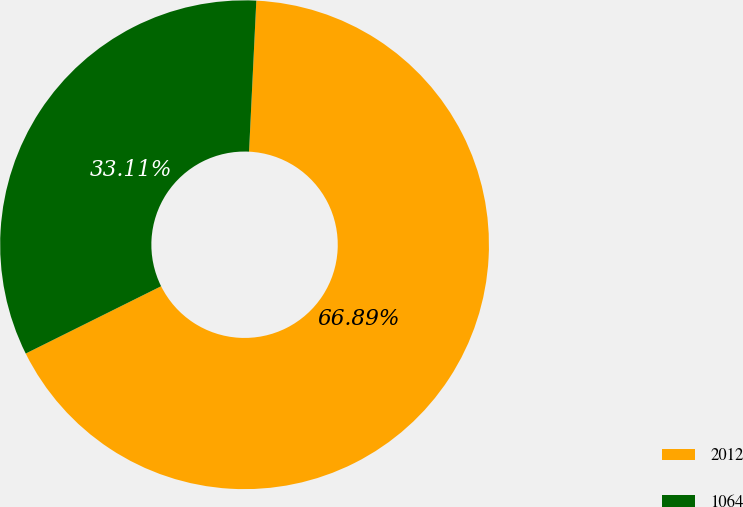<chart> <loc_0><loc_0><loc_500><loc_500><pie_chart><fcel>2012<fcel>1064<nl><fcel>66.89%<fcel>33.11%<nl></chart> 